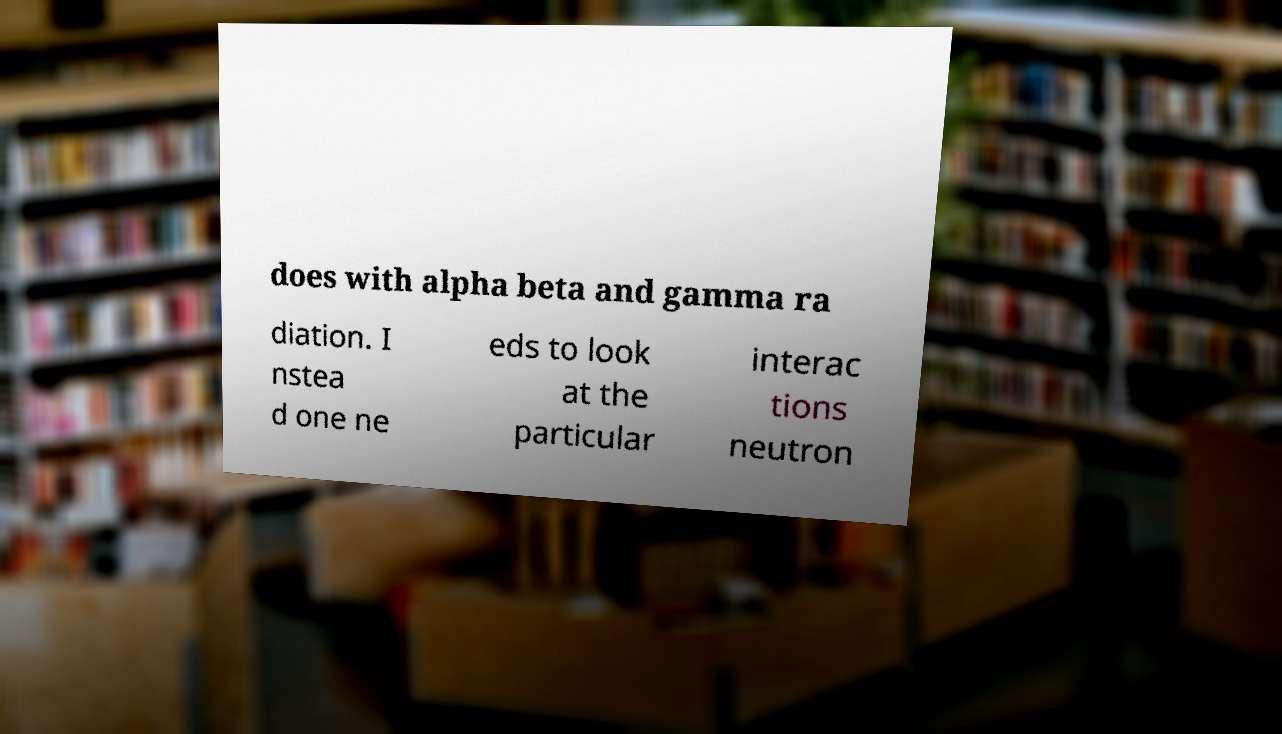Can you read and provide the text displayed in the image?This photo seems to have some interesting text. Can you extract and type it out for me? does with alpha beta and gamma ra diation. I nstea d one ne eds to look at the particular interac tions neutron 